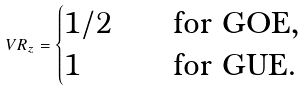Convert formula to latex. <formula><loc_0><loc_0><loc_500><loc_500>V R _ { z } = \begin{cases} 1 / 2 & \quad \text {for GOE, } \\ 1 & \quad \text {for GUE. } \end{cases}</formula> 